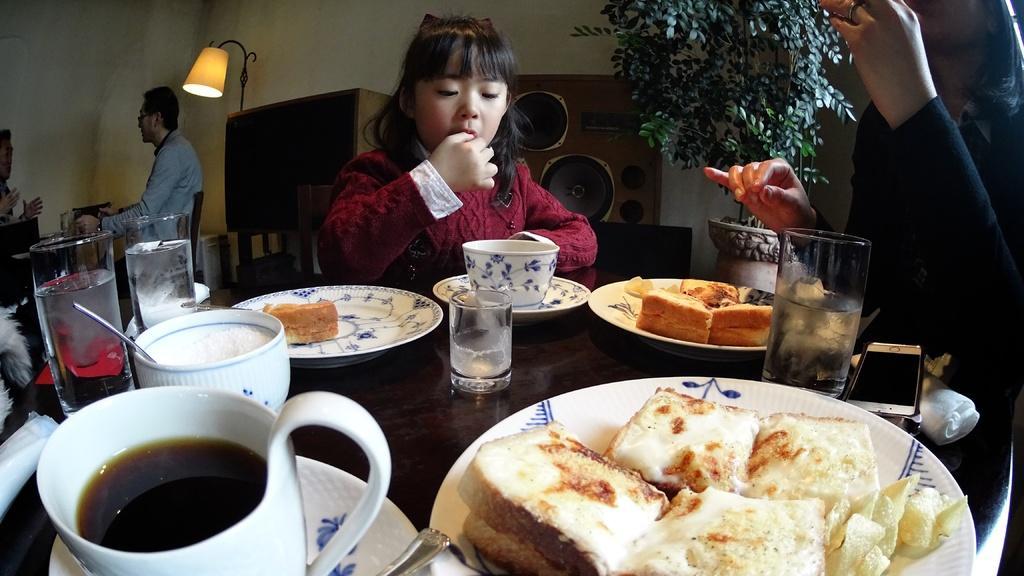In one or two sentences, can you explain what this image depicts? There are glasses, cups, saucers and food items on the table in the foreground area of the image, there are people sitting in front of the tables, it seems like desks, plant and a lamp in the background. 